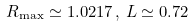Convert formula to latex. <formula><loc_0><loc_0><loc_500><loc_500>R _ { \max } \simeq 1 . 0 2 1 7 \, , \, L \simeq 0 . 7 2</formula> 